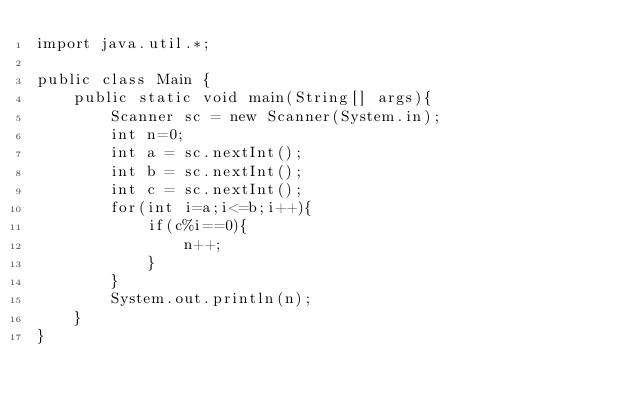<code> <loc_0><loc_0><loc_500><loc_500><_Java_>import java.util.*;

public class Main {
	public static void main(String[] args){
		Scanner sc = new Scanner(System.in);
		int n=0;
		int a = sc.nextInt();
		int b = sc.nextInt();
		int c = sc.nextInt();
		for(int i=a;i<=b;i++){
			if(c%i==0){
				n++;
			}
		}
		System.out.println(n);
	}
}</code> 